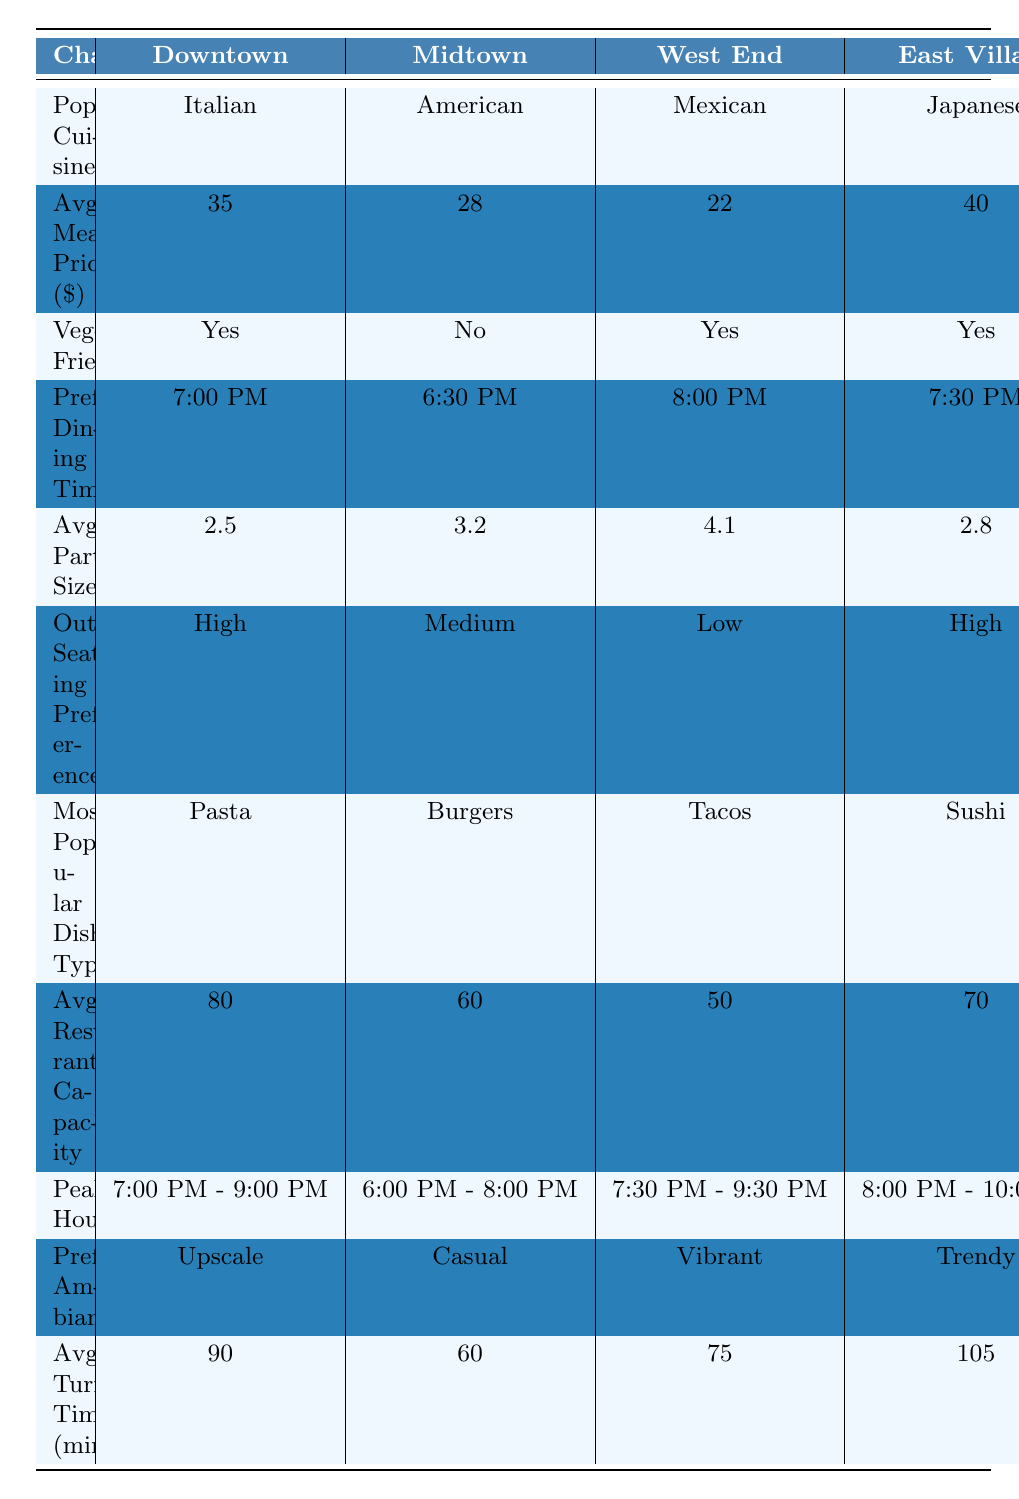What is the most popular cuisine in Midtown? By looking at the table, the row for "Popular Cuisine" under the Midtown column shows "American."
Answer: American Which neighborhood has the highest average meal price? The average meal prices listed are 35, 28, 22, 40, and 30 for Downtown, Midtown, West End, East Village, and Riverside respectively. The highest value is 40, which corresponds to East Village.
Answer: East Village Is Riverside vegetarian-friendly? The table shows that the "Vegetarian Friendly" for Riverside is marked as Yes.
Answer: Yes What is the average party size in the West End? The table indicates the average party size for the West End is 4.1.
Answer: 4.1 Which neighborhood has the "Very High" outdoor seating preference? The table lists outdoor seating preferences, and "Very High" is indicated for Riverside.
Answer: Riverside How does the average meal price in Downtown compare to the average meal price in West End? The average meal price in Downtown is 35 and in West End is 22. The difference is calculated as 35 - 22 = 13.
Answer: 13 What is the preferred dining time in Downtown? Looking at the "Preferred Dining Time" column, Downtown has a dining time of 7:00 PM.
Answer: 7:00 PM Which neighborhood has the most popular dish type of "Sushi"? The table shows "Sushi" as the most popular dish type for East Village.
Answer: East Village What is the average restaurant capacity across all neighborhoods? To find the average capacity, sum the capacities: (80 + 60 + 50 + 70 + 90) = 350, then divide by the number of neighborhoods (5): 350 / 5 = 70.
Answer: 70 In which neighborhood are the peak hours from 8:00 PM to 10:00 PM? The table indicates the peak hours for East Village are from 8:00 PM to 10:00 PM.
Answer: East Village How many neighborhoods have a vegetarian-friendly option? The table shows vegetarian-friendly options for Downtown, West End, East Village, and Riverside. That makes a total of 4 neighborhoods.
Answer: 4 What is the average turnover time across all neighborhoods? Adding the turnover times: (90 + 60 + 75 + 105 + 85) = 415, then divide by 5 gives us an average turnover time of 83 minutes.
Answer: 83 Which neighborhood has a "Casual" preferred ambiance? The table shows that the preferred ambiance for Midtown is labeled as "Casual."
Answer: Midtown What is the difference in average meal price between the East Village and Riverside? The average meal price for East Village is 40 and for Riverside is 30. The difference is 40 - 30 = 10.
Answer: 10 Which neighborhood has the smallest average restaurant capacity? The table indicates that the West End has the smallest average restaurant capacity, which is 50.
Answer: West End 